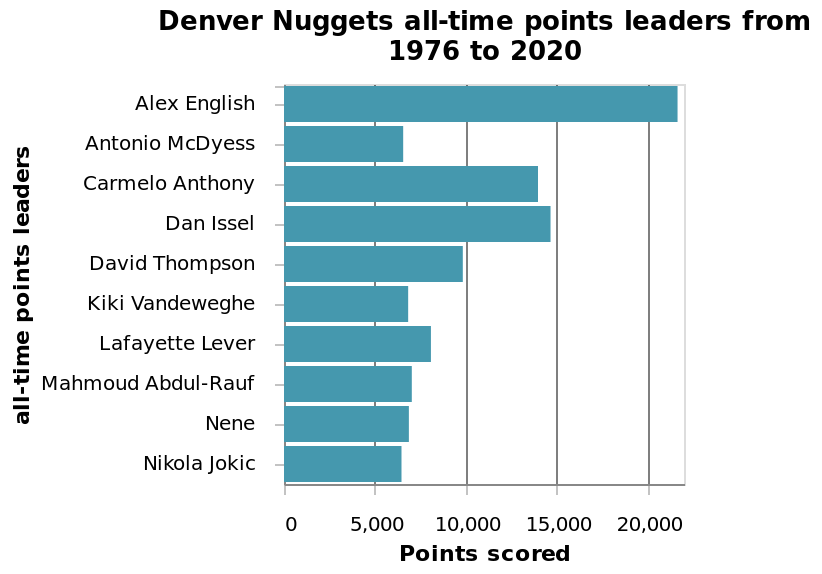<image>
Describe the following image in detail Here a bar graph is labeled Denver Nuggets all-time points leaders from 1976 to 2020. all-time points leaders is defined with a categorical scale starting with Alex English and ending with  along the y-axis. The x-axis measures Points scored using a linear scale with a minimum of 0 and a maximum of 20,000. How many players were in the category 'up to 14000 points'?  Two players were in the category 'up to 14000 points'. Who was the player that was exceptionally above all other players during the 44 years?  The player who was exceptionally above all other players during the 44 years was Alex English. What is the maximum value on the x-axis of the bar graph? The maximum value on the x-axis is 20,000. Is a bar graph labeled Denver Nuggets all-time points leaders from 1976 to 2020? No.Here a bar graph is labeled Denver Nuggets all-time points leaders from 1976 to 2020. all-time points leaders is defined with a categorical scale starting with Alex English and ending with  along the y-axis. The x-axis measures Points scored using a linear scale with a minimum of 0 and a maximum of 20,000. 